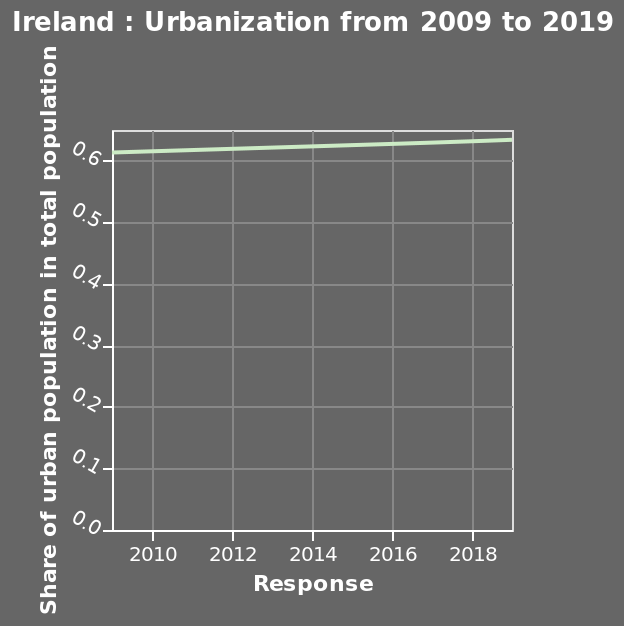<image>
What is the name of the line plot?  The line plot is called "Ireland: Urbanization from 2009 to 2019." 